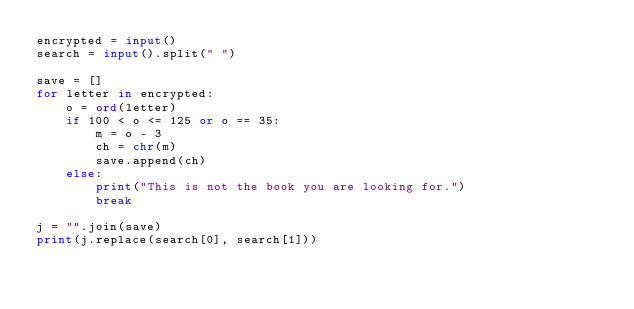<code> <loc_0><loc_0><loc_500><loc_500><_Python_>encrypted = input()
search = input().split(" ")

save = []
for letter in encrypted:
    o = ord(letter)
    if 100 < o <= 125 or o == 35:
        m = o - 3
        ch = chr(m)
        save.append(ch)
    else:
        print("This is not the book you are looking for.")
        break

j = "".join(save)
print(j.replace(search[0], search[1]))</code> 